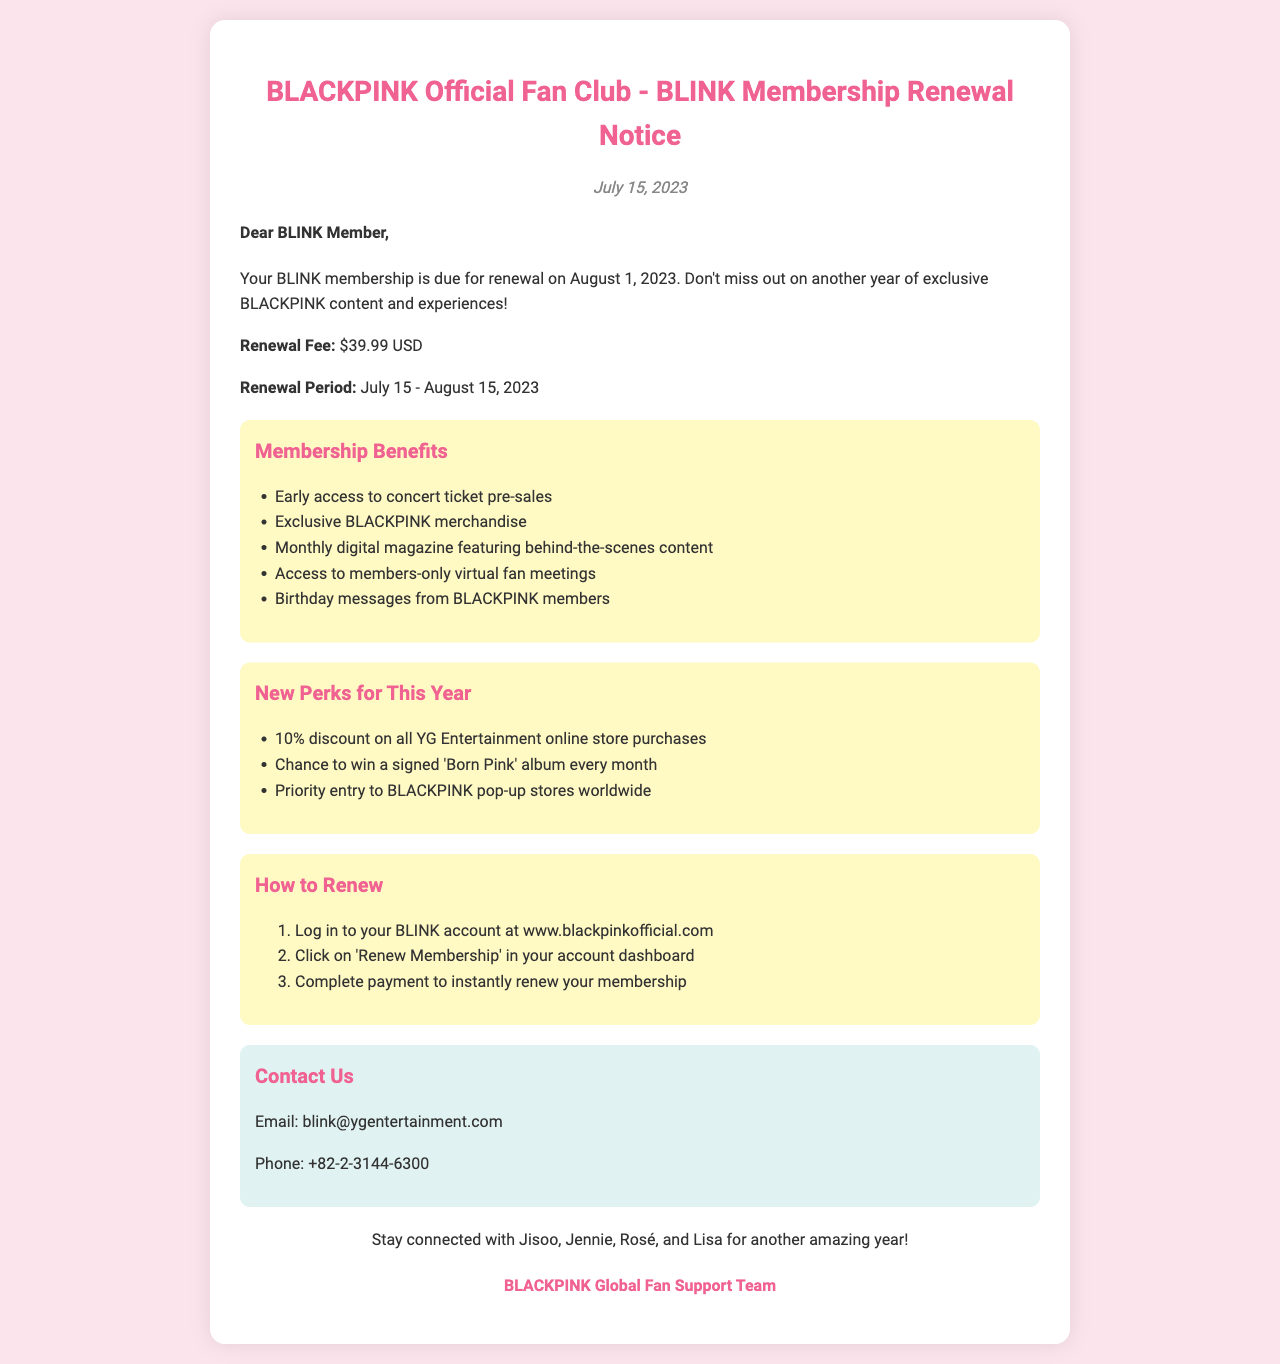What is the renewal fee? The renewal fee is stated in the document as the amount required to maintain membership, which is $39.99 USD.
Answer: $39.99 USD What is the renewal period? The renewal period indicates the timeframe during which members must renew, which is from July 15 to August 15, 2023.
Answer: July 15 - August 15, 2023 What are the early access benefits? The document outlines specific benefits, including "Early access to concert ticket pre-sales" as a part of membership benefits.
Answer: Early access to concert ticket pre-sales What new perk is included for this year? The document lists new perks, one being "10% discount on all YG Entertainment online store purchases."
Answer: 10% discount on all YG Entertainment online store purchases How do you renew the membership? The document provides specific instructions on how to renew membership, starting with logging into your BLINK account at the official website.
Answer: Log in to your BLINK account at www.blackpinkofficial.com Which members send birthday messages? The document specifically mentions that birthday messages come from all four BLACKPINK members: Jisoo, Jennie, Rosé, and Lisa.
Answer: Jisoo, Jennie, Rosé, and Lisa What must you complete after clicking 'Renew Membership'? After clicking 'Renew Membership', the document states that you have to complete payment to renew your membership instantly.
Answer: Complete payment What should you do if you have questions? The contact information section provides an option for members to reach out via email for any inquiries, showing how to contact support.
Answer: Email: blink@ygentertainment.com What date is the membership renewal notice sent? The document includes a specific date on which the renewal notice is issued, which is July 15, 2023.
Answer: July 15, 2023 